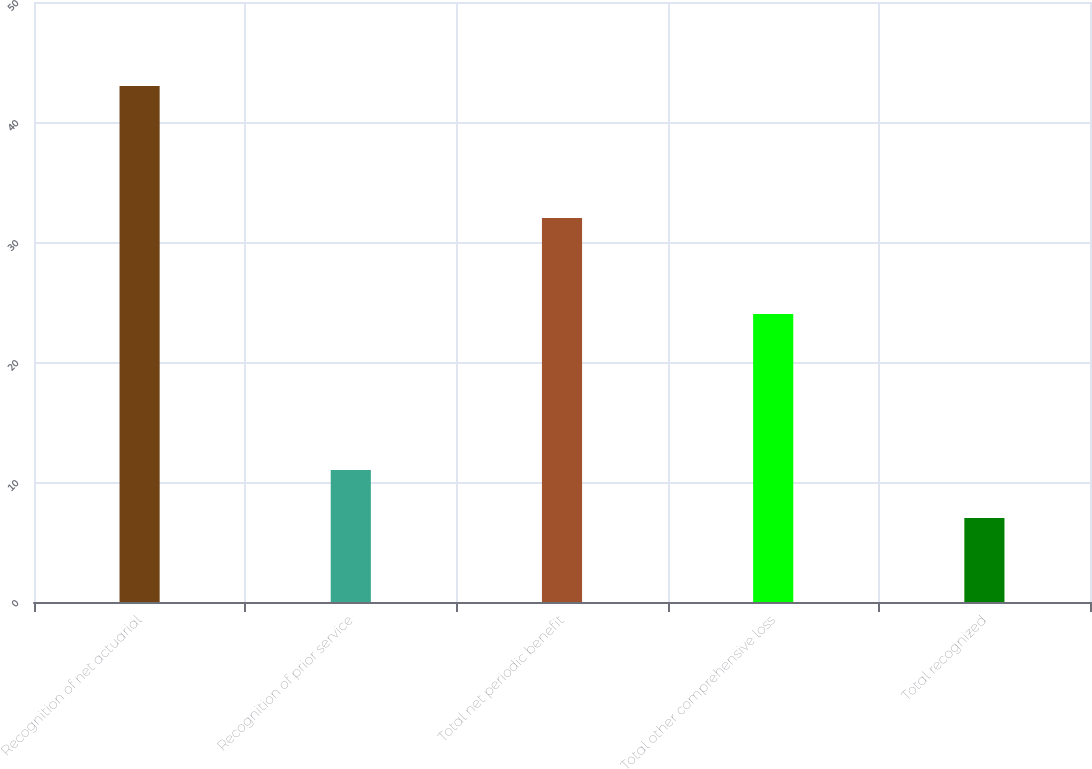Convert chart. <chart><loc_0><loc_0><loc_500><loc_500><bar_chart><fcel>Recognition of net actuarial<fcel>Recognition of prior service<fcel>Total net periodic benefit<fcel>Total other comprehensive loss<fcel>Total recognized<nl><fcel>43<fcel>11<fcel>32<fcel>24<fcel>7<nl></chart> 